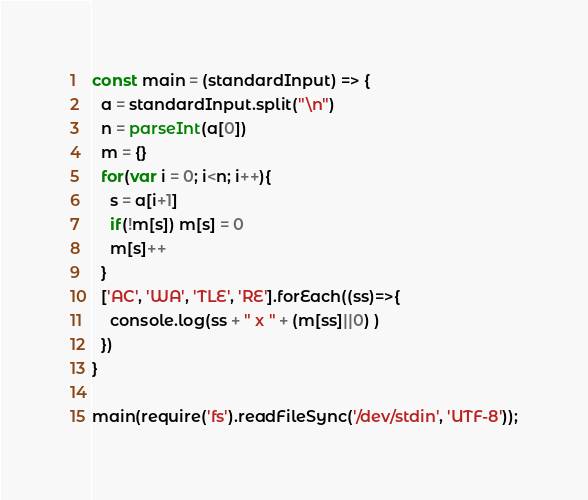Convert code to text. <code><loc_0><loc_0><loc_500><loc_500><_JavaScript_>const main = (standardInput) => {
  a = standardInput.split("\n")
  n = parseInt(a[0])
  m = {}
  for(var i = 0; i<n; i++){
    s = a[i+1]
    if(!m[s]) m[s] = 0
    m[s]++
  }
  ['AC', 'WA', 'TLE', 'RE'].forEach((ss)=>{
    console.log(ss + " x " + (m[ss]||0) )
  })
}

main(require('fs').readFileSync('/dev/stdin', 'UTF-8'));</code> 